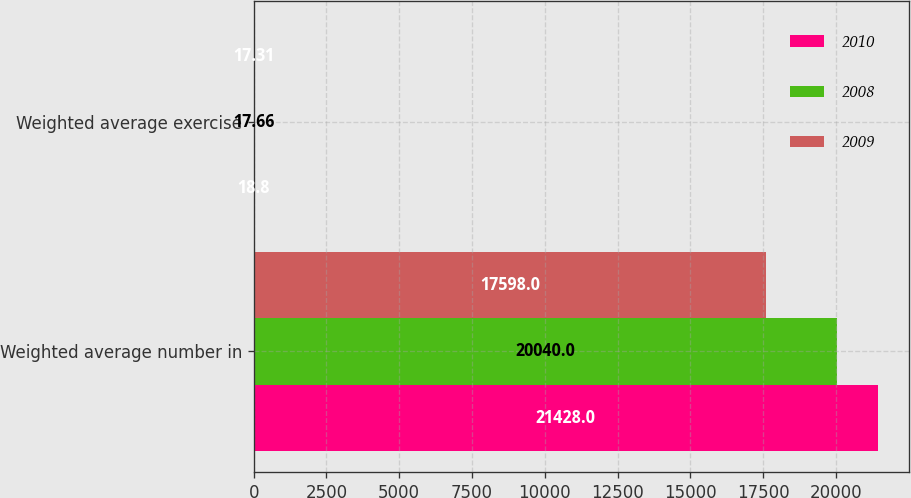Convert chart. <chart><loc_0><loc_0><loc_500><loc_500><stacked_bar_chart><ecel><fcel>Weighted average number in<fcel>Weighted average exercise<nl><fcel>2010<fcel>21428<fcel>18.8<nl><fcel>2008<fcel>20040<fcel>17.66<nl><fcel>2009<fcel>17598<fcel>17.31<nl></chart> 